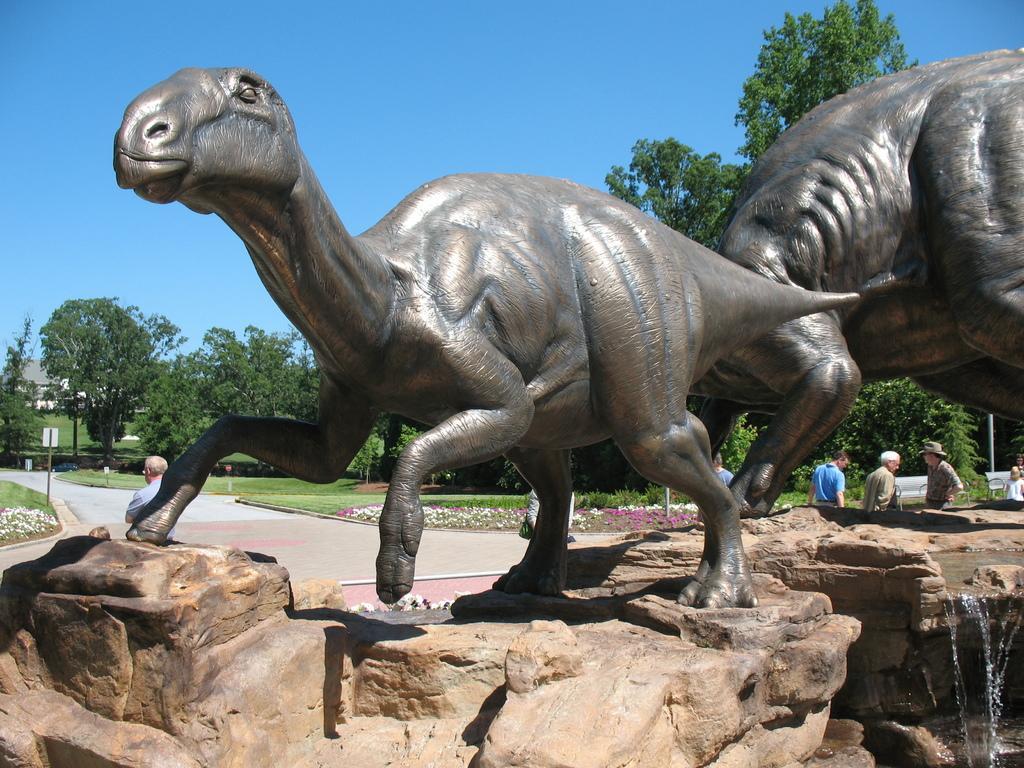Describe this image in one or two sentences. In the center of the image we can see the statues. In the background of the image we can see the trees, board, house, grass, plants, flowers, poles and some persons, bench. At the bottom of the image we can see the rocks and water. In the middle of the image we can see the road. At the top of the image we can see the sky. 